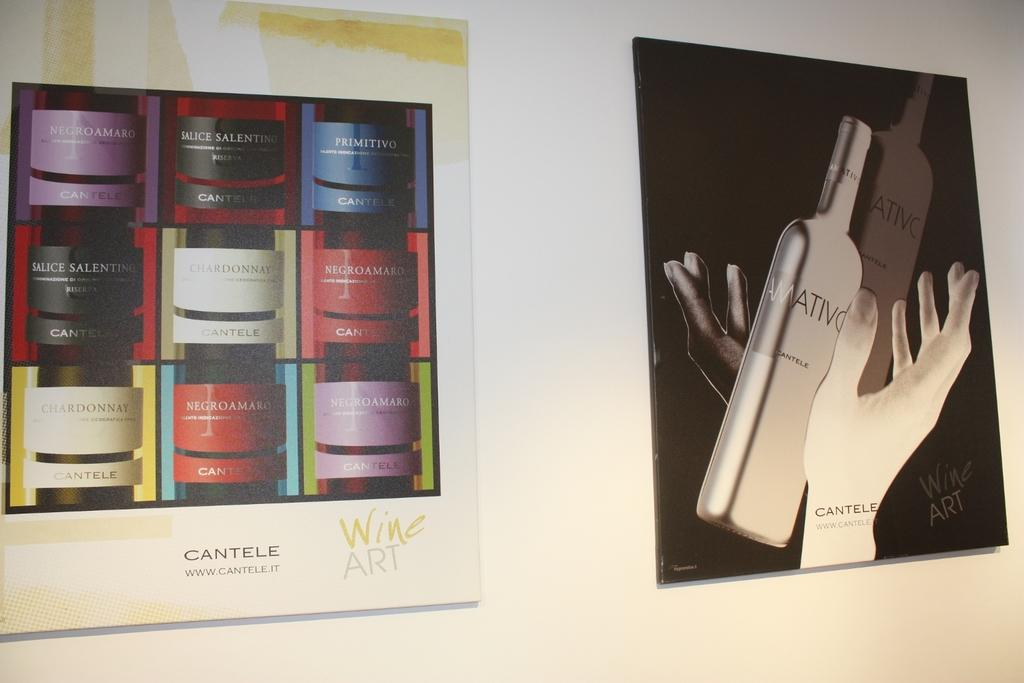<image>
Provide a brief description of the given image. An ad for Cantele shows several different products in a grid pattern. 